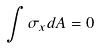<formula> <loc_0><loc_0><loc_500><loc_500>\int \sigma _ { x } d A = 0</formula> 